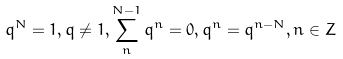Convert formula to latex. <formula><loc_0><loc_0><loc_500><loc_500>q ^ { N } = 1 , q \ne 1 , \sum _ { n } ^ { N - 1 } q ^ { n } = 0 , q ^ { n } = q ^ { n - N } , n \in Z</formula> 